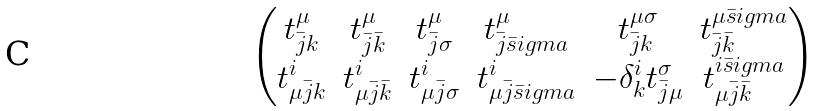<formula> <loc_0><loc_0><loc_500><loc_500>\begin{pmatrix} t ^ { \mu } _ { \bar { j } k } & t ^ { \mu } _ { \bar { j } \bar { k } } & t ^ { \mu } _ { \bar { j } \sigma } & t ^ { \mu } _ { \bar { j } \bar { s } i g m a } & t ^ { \mu \sigma } _ { \bar { j } k } & t ^ { \mu \bar { s } i g m a } _ { \bar { j } \bar { k } } \\ t ^ { i } _ { \mu \bar { j } k } & t ^ { i } _ { \mu \bar { j } \bar { k } } & t ^ { i } _ { \mu \bar { j } \sigma } & t ^ { i } _ { \mu \bar { j } \bar { s } i g m a } & - \delta ^ { i } _ { k } t ^ { \sigma } _ { \bar { j } \mu } & t ^ { i \bar { s } i g m a } _ { \mu \bar { j } \bar { k } } \end{pmatrix}</formula> 